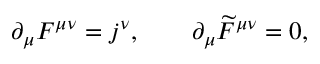<formula> <loc_0><loc_0><loc_500><loc_500>\partial _ { \mu } F ^ { \mu \nu } = j ^ { \nu } , \quad \partial _ { \mu } \widetilde { F } ^ { \mu \nu } = 0 ,</formula> 